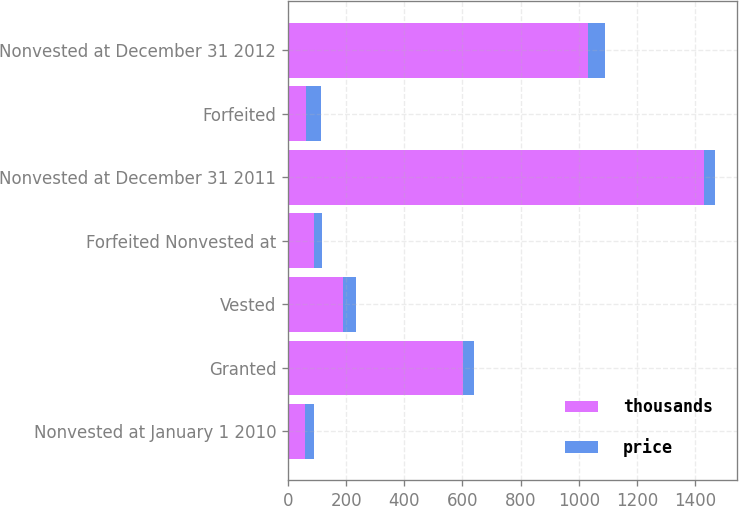<chart> <loc_0><loc_0><loc_500><loc_500><stacked_bar_chart><ecel><fcel>Nonvested at January 1 2010<fcel>Granted<fcel>Vested<fcel>Forfeited Nonvested at<fcel>Nonvested at December 31 2011<fcel>Forfeited<fcel>Nonvested at December 31 2012<nl><fcel>thousands<fcel>58.77<fcel>603<fcel>188<fcel>91<fcel>1430<fcel>61<fcel>1032<nl><fcel>price<fcel>29.9<fcel>36.16<fcel>44.8<fcel>27.1<fcel>39.02<fcel>54.35<fcel>58.77<nl></chart> 